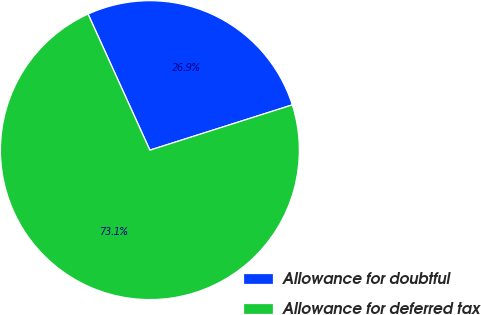Convert chart to OTSL. <chart><loc_0><loc_0><loc_500><loc_500><pie_chart><fcel>Allowance for doubtful<fcel>Allowance for deferred tax<nl><fcel>26.89%<fcel>73.11%<nl></chart> 